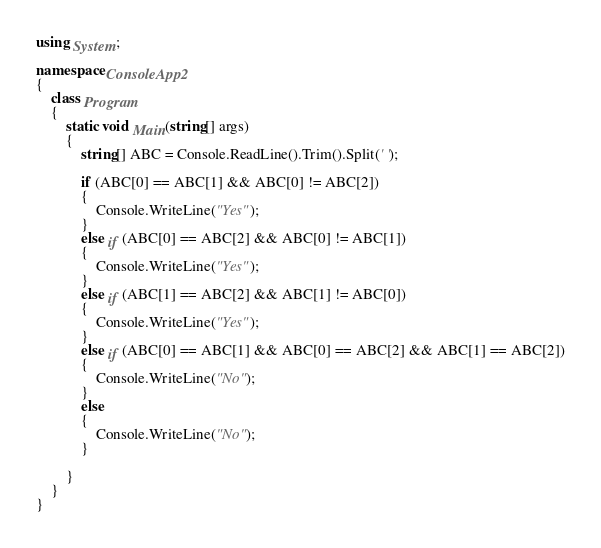Convert code to text. <code><loc_0><loc_0><loc_500><loc_500><_C#_>using System;

namespace ConsoleApp2
{
    class Program
    {
        static void Main(string[] args)
        {
            string[] ABC = Console.ReadLine().Trim().Split(' ');

            if (ABC[0] == ABC[1] && ABC[0] != ABC[2])
            {
                Console.WriteLine("Yes");
            }
            else if (ABC[0] == ABC[2] && ABC[0] != ABC[1])
            {
                Console.WriteLine("Yes");
            }
            else if (ABC[1] == ABC[2] && ABC[1] != ABC[0])
            {
                Console.WriteLine("Yes");
            }
            else if (ABC[0] == ABC[1] && ABC[0] == ABC[2] && ABC[1] == ABC[2])
            {
                Console.WriteLine("No");
            }
            else
            {
                Console.WriteLine("No");
            }

        }
    }
}</code> 